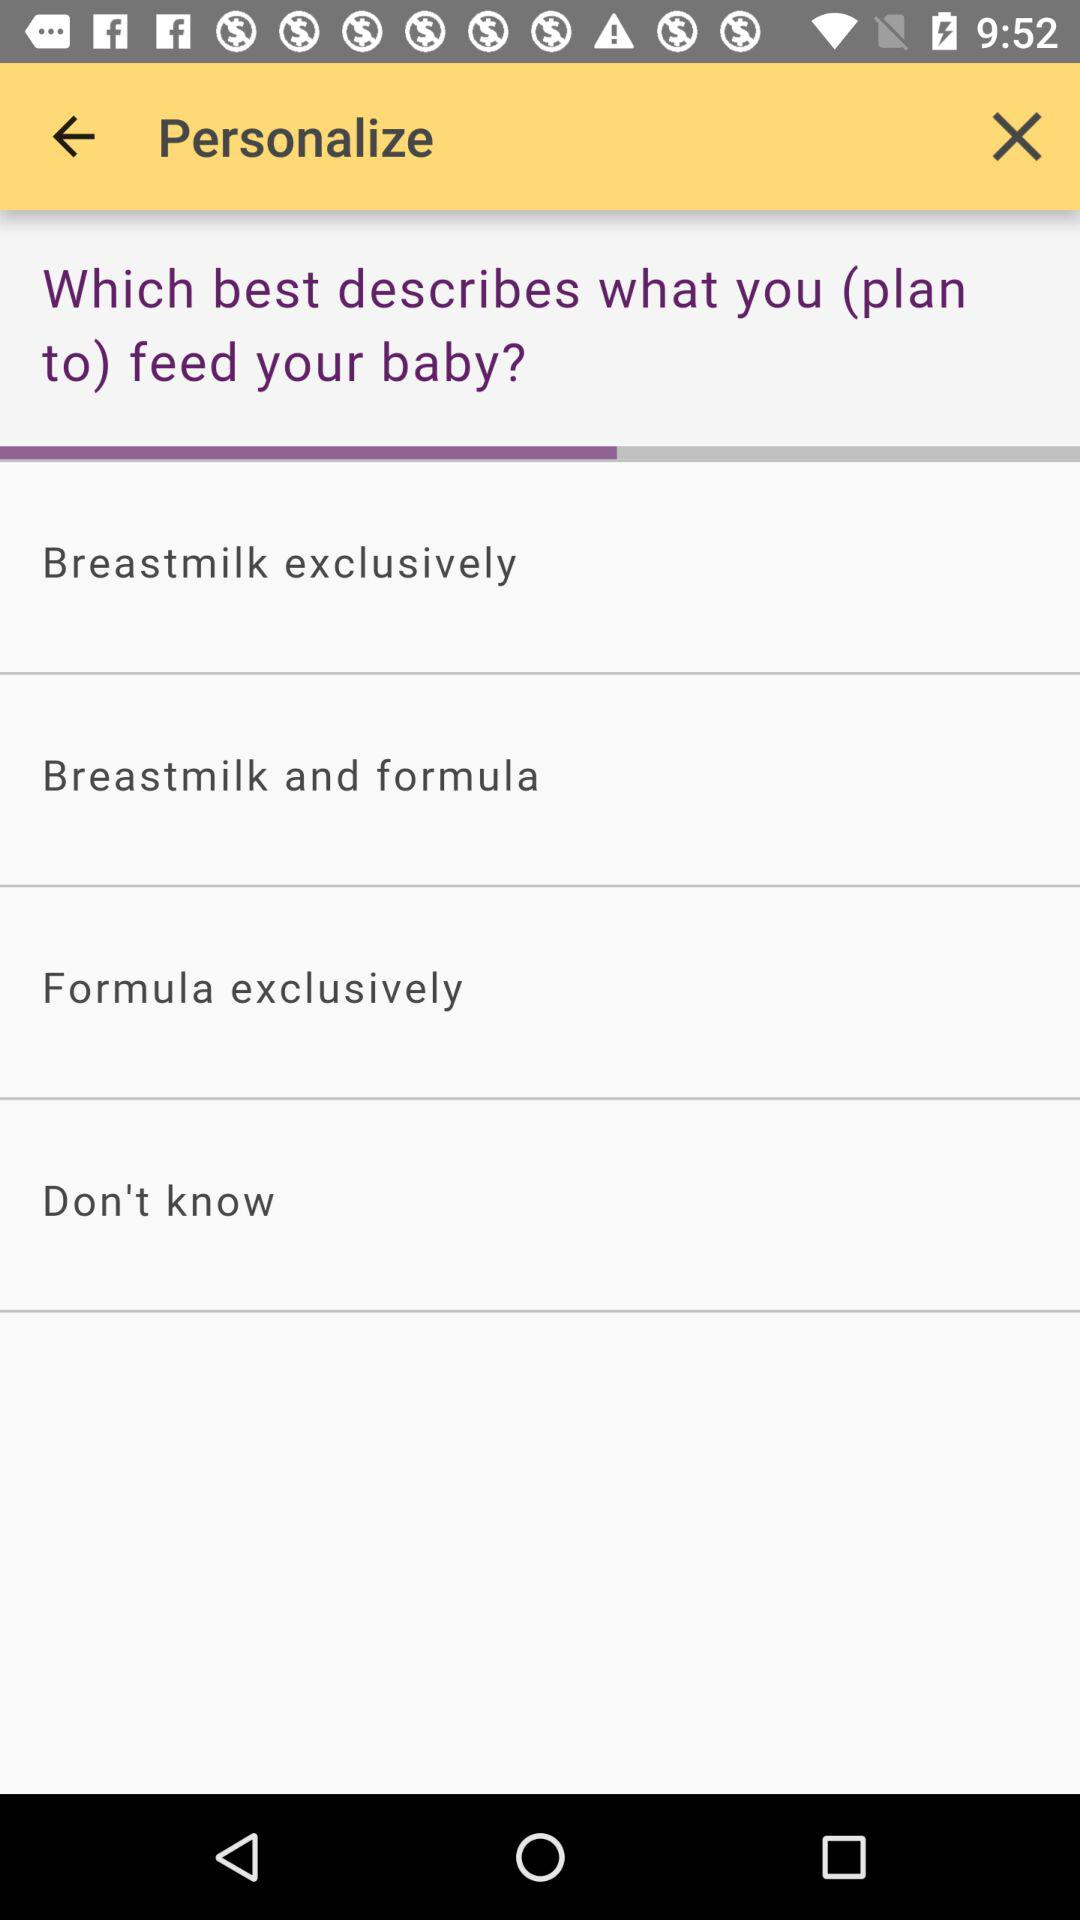How many options are there for feeding my baby?
Answer the question using a single word or phrase. 4 